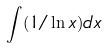<formula> <loc_0><loc_0><loc_500><loc_500>\int ( 1 / \ln x ) d x</formula> 